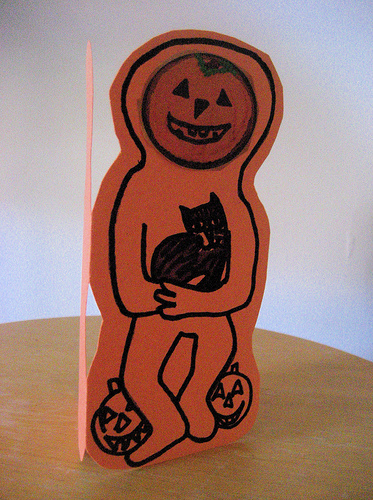<image>
Is the cat on the pumpkin? No. The cat is not positioned on the pumpkin. They may be near each other, but the cat is not supported by or resting on top of the pumpkin. Where is the card in relation to the table? Is it next to the table? No. The card is not positioned next to the table. They are located in different areas of the scene. 